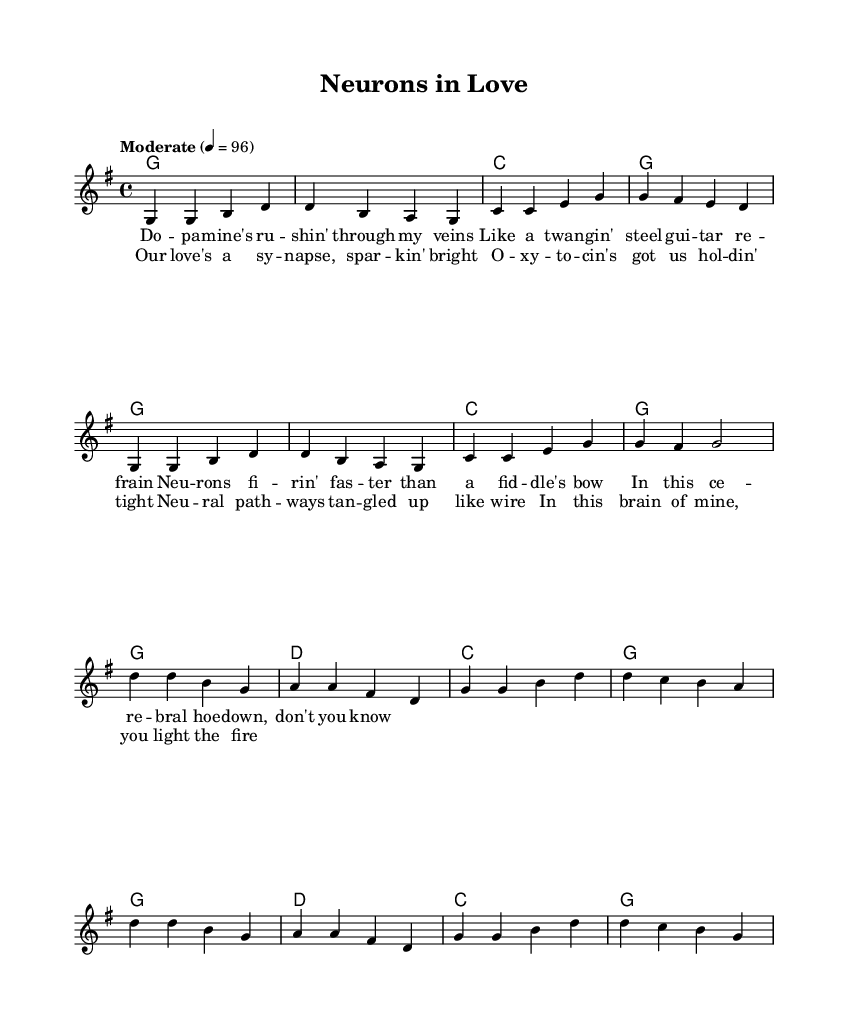What is the key signature of this music? The key signature is G major, which has one sharp (F#). This is indicated at the beginning of the music sheet.
Answer: G major What is the time signature of this music? The time signature is 4/4, which means there are four beats per measure and the quarter note receives one beat. This is noted at the beginning of the sheet music.
Answer: 4/4 What is the tempo of the piece? The tempo is indicated as "Moderate" at a speed of 96 beats per minute. This provides guidance on the intended speed of the performance.
Answer: 96 How many measures are in the verse section? The verse section consists of two sets of eight measures, making a total of 16 measures. Counting each measure shows they are grouped in two identical sections.
Answer: 16 What musical form does this song follow? The song follows a verse-chorus structure, common in country music, where it alternates between verses and choruses. This can be seen from the layout of the melody and lyrics.
Answer: Verse-Chorus What instrument plays the melody in this arrangement? The melody is played by a lead voice indicated in the score. The score label shows that it is primarily for vocal performance, characteristic of country music.
Answer: Lead voice What lyrical theme is expressed in the chorus? The chorus expresses a theme of love, using imagery related to brain chemistry and neural connections, which is a unique lyrical perspective in traditional country music.
Answer: Love and neural connections 